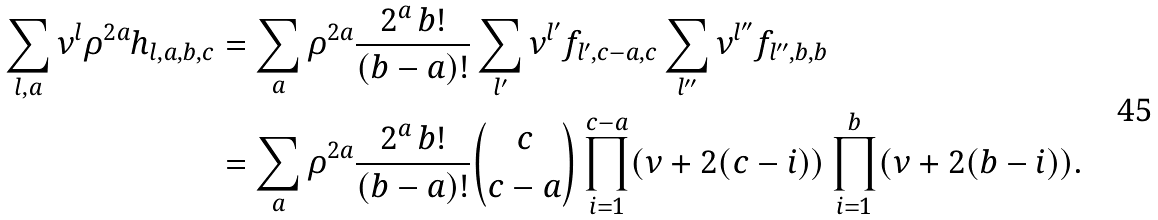Convert formula to latex. <formula><loc_0><loc_0><loc_500><loc_500>\sum _ { l , a } \nu ^ { l } \rho ^ { 2 a } h _ { l , a , b , c } & = \sum _ { a } \rho ^ { 2 a } \frac { 2 ^ { a } \, b ! } { ( b - a ) ! } \sum _ { l ^ { \prime } } \nu ^ { l ^ { \prime } } f _ { l ^ { \prime } , c - a , c } \sum _ { l ^ { \prime \prime } } \nu ^ { l ^ { \prime \prime } } f _ { l ^ { \prime \prime } , b , b } \\ & = \sum _ { a } \rho ^ { 2 a } \frac { 2 ^ { a } \, b ! } { ( b - a ) ! } { c \choose c - a } \prod _ { i = 1 } ^ { c - a } ( \nu + 2 ( c - i ) ) \prod _ { i = 1 } ^ { b } ( \nu + 2 ( b - i ) ) .</formula> 